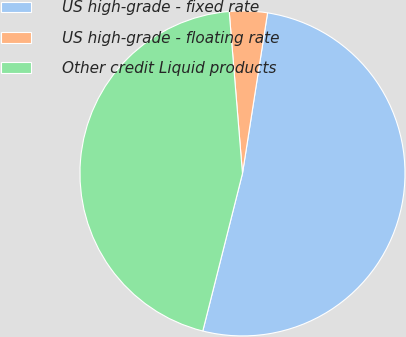Convert chart. <chart><loc_0><loc_0><loc_500><loc_500><pie_chart><fcel>US high-grade - fixed rate<fcel>US high-grade - floating rate<fcel>Other credit Liquid products<nl><fcel>51.46%<fcel>3.77%<fcel>44.77%<nl></chart> 